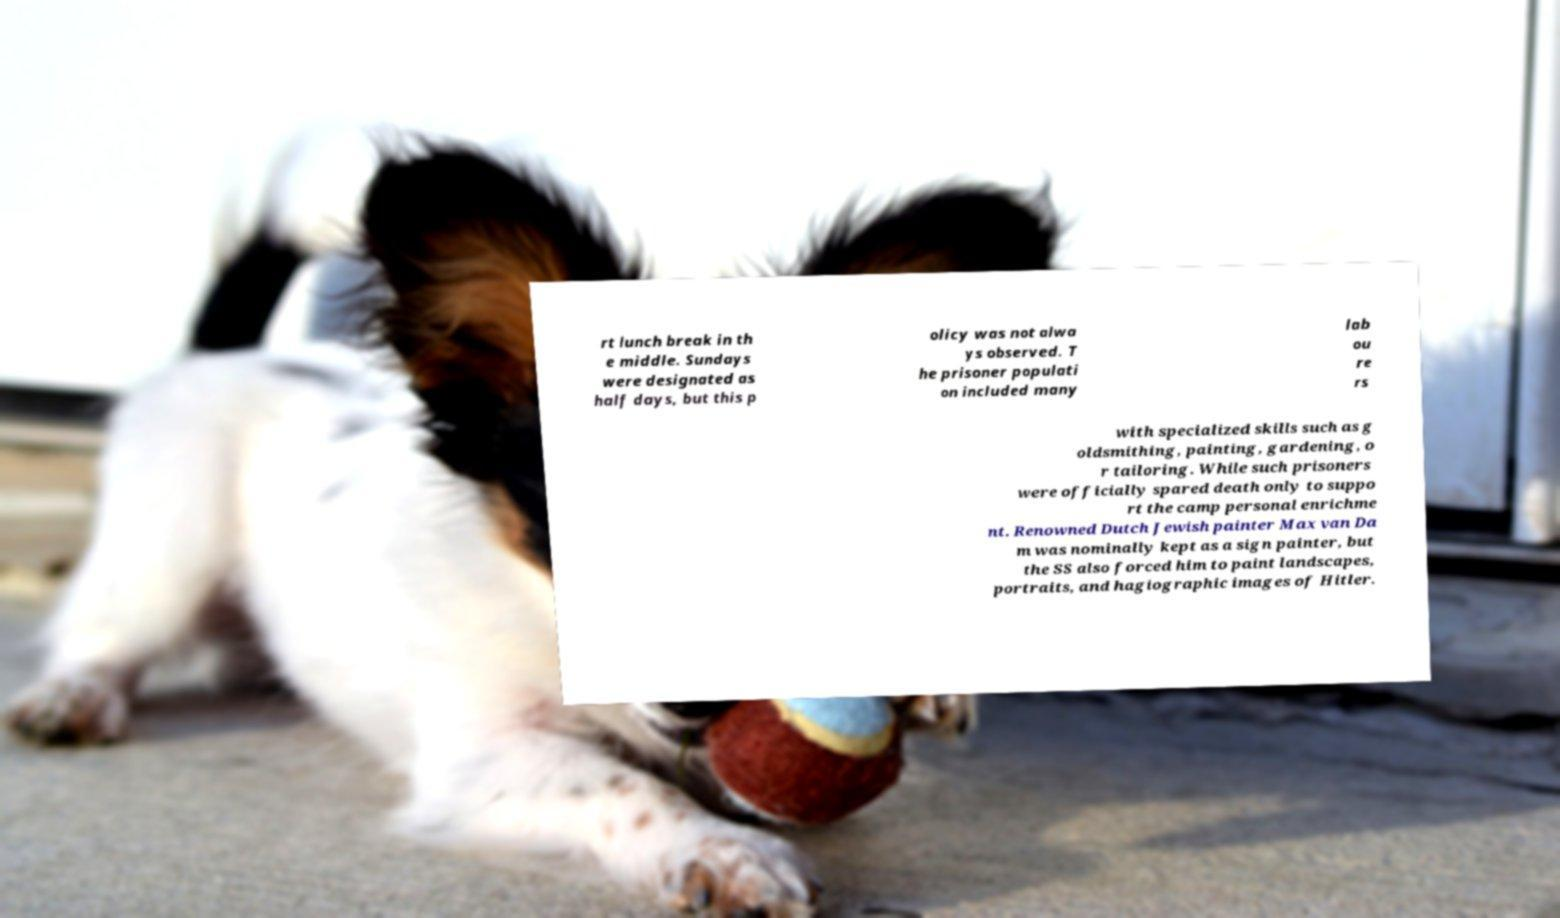Can you accurately transcribe the text from the provided image for me? rt lunch break in th e middle. Sundays were designated as half days, but this p olicy was not alwa ys observed. T he prisoner populati on included many lab ou re rs with specialized skills such as g oldsmithing, painting, gardening, o r tailoring. While such prisoners were officially spared death only to suppo rt the camp personal enrichme nt. Renowned Dutch Jewish painter Max van Da m was nominally kept as a sign painter, but the SS also forced him to paint landscapes, portraits, and hagiographic images of Hitler. 